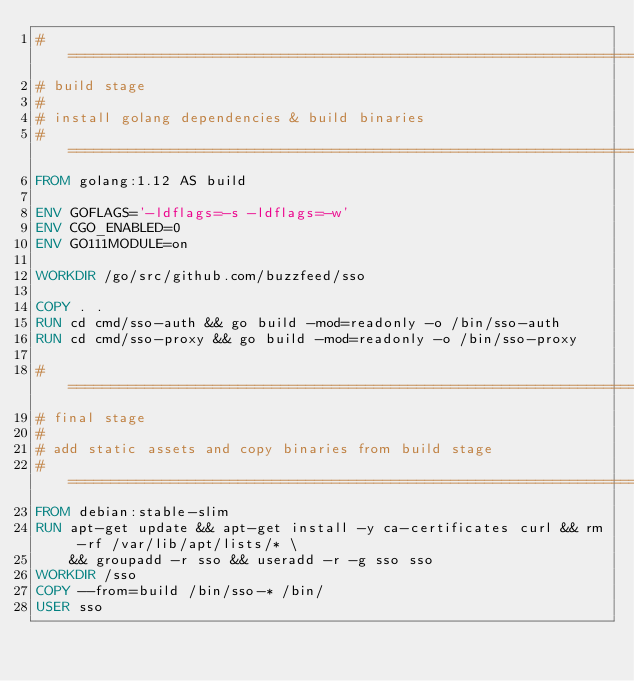Convert code to text. <code><loc_0><loc_0><loc_500><loc_500><_Dockerfile_># =============================================================================
# build stage
#
# install golang dependencies & build binaries
# =============================================================================
FROM golang:1.12 AS build

ENV GOFLAGS='-ldflags=-s -ldflags=-w'
ENV CGO_ENABLED=0
ENV GO111MODULE=on

WORKDIR /go/src/github.com/buzzfeed/sso

COPY . .
RUN cd cmd/sso-auth && go build -mod=readonly -o /bin/sso-auth
RUN cd cmd/sso-proxy && go build -mod=readonly -o /bin/sso-proxy

# =============================================================================
# final stage
#
# add static assets and copy binaries from build stage
# =============================================================================
FROM debian:stable-slim
RUN apt-get update && apt-get install -y ca-certificates curl && rm -rf /var/lib/apt/lists/* \
    && groupadd -r sso && useradd -r -g sso sso
WORKDIR /sso
COPY --from=build /bin/sso-* /bin/
USER sso
</code> 